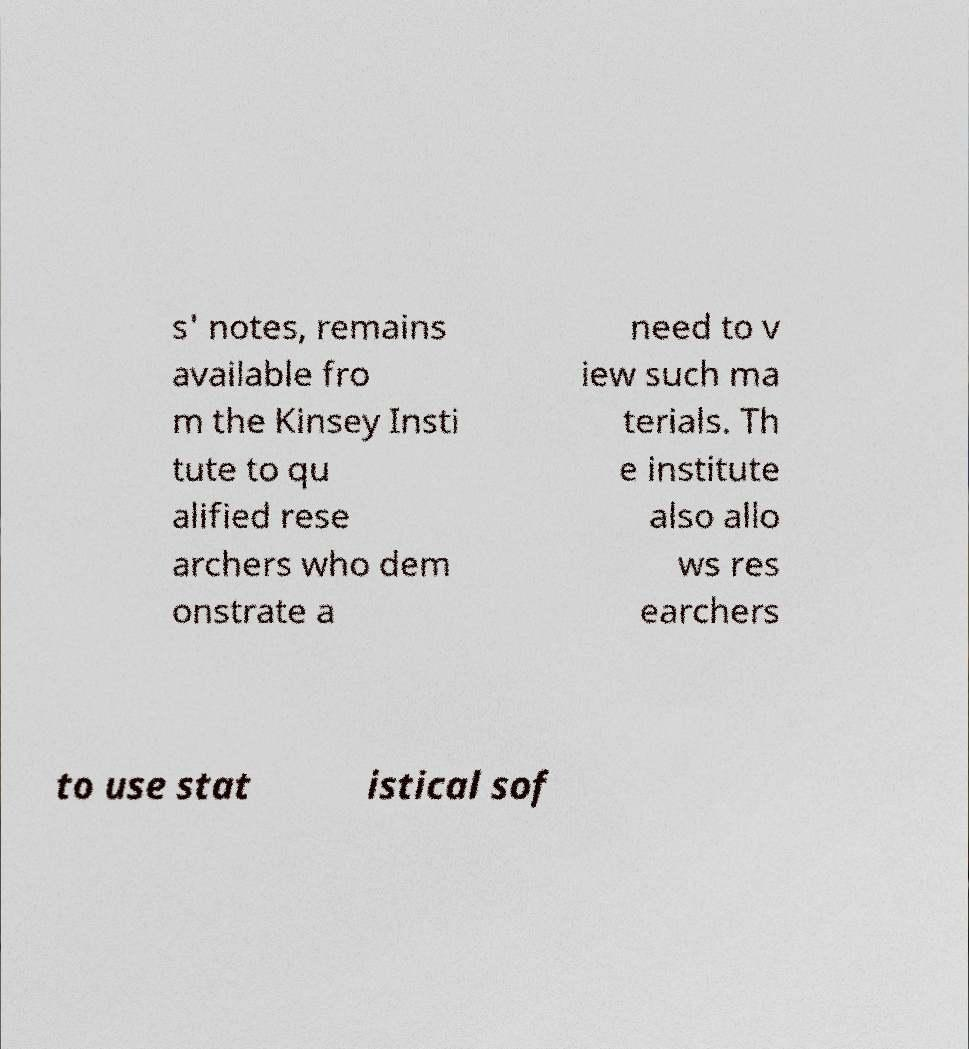There's text embedded in this image that I need extracted. Can you transcribe it verbatim? s' notes, remains available fro m the Kinsey Insti tute to qu alified rese archers who dem onstrate a need to v iew such ma terials. Th e institute also allo ws res earchers to use stat istical sof 